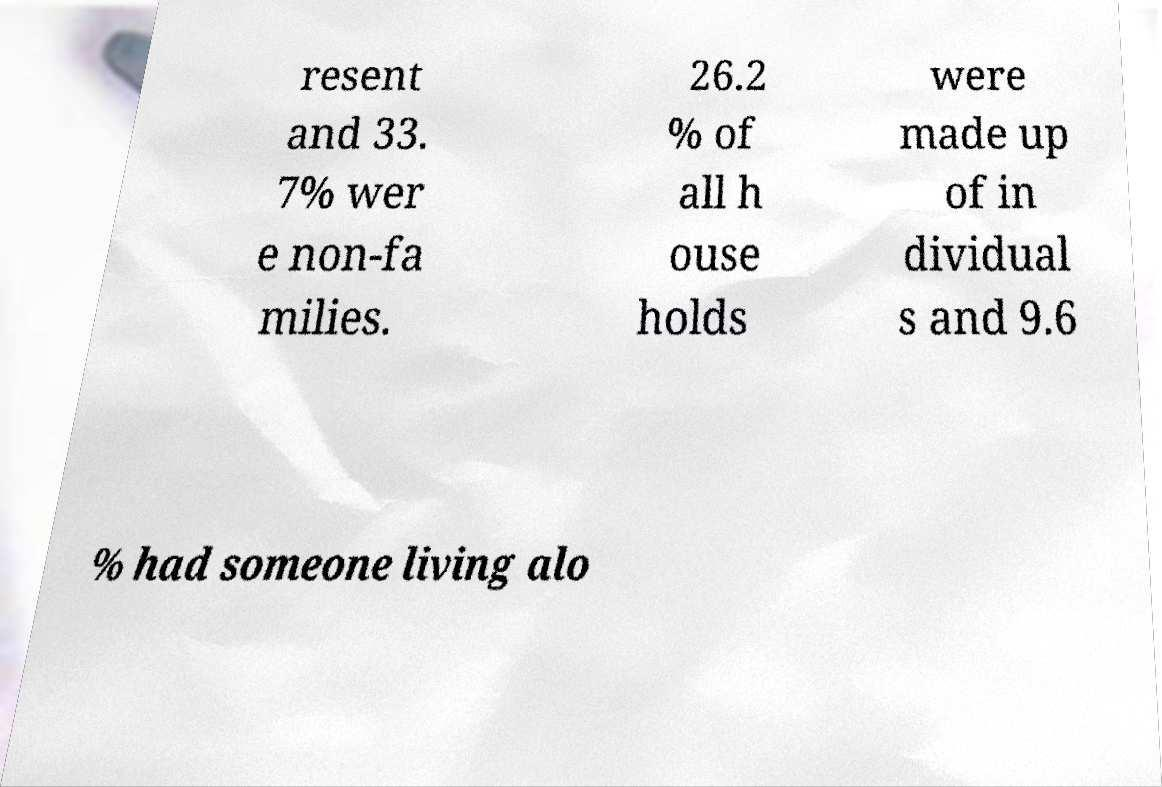Could you assist in decoding the text presented in this image and type it out clearly? resent and 33. 7% wer e non-fa milies. 26.2 % of all h ouse holds were made up of in dividual s and 9.6 % had someone living alo 